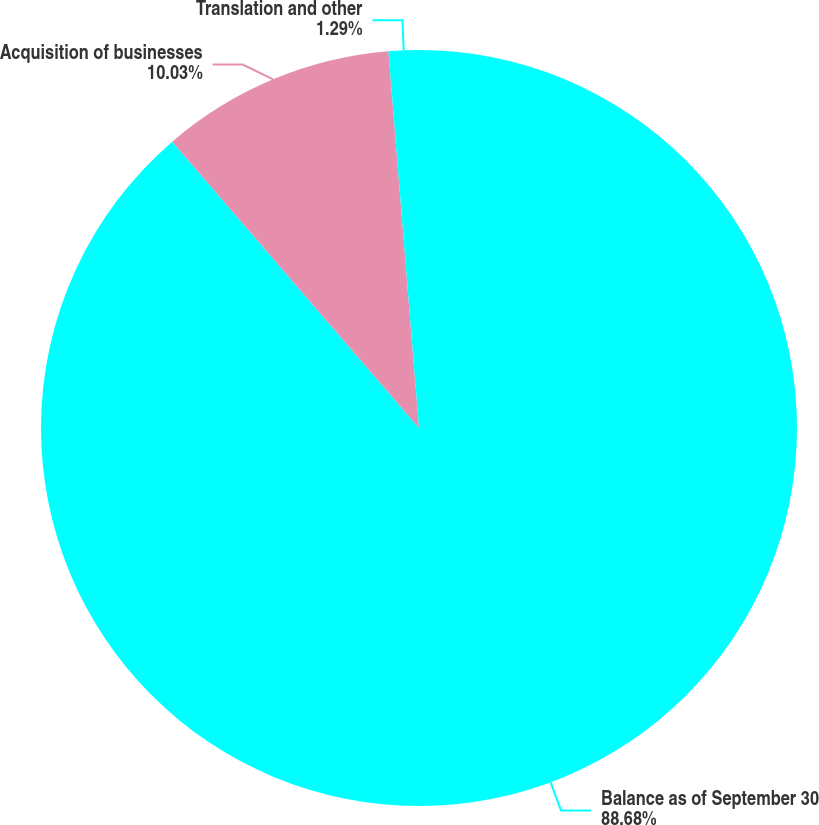<chart> <loc_0><loc_0><loc_500><loc_500><pie_chart><fcel>Balance as of September 30<fcel>Acquisition of businesses<fcel>Translation and other<nl><fcel>88.68%<fcel>10.03%<fcel>1.29%<nl></chart> 